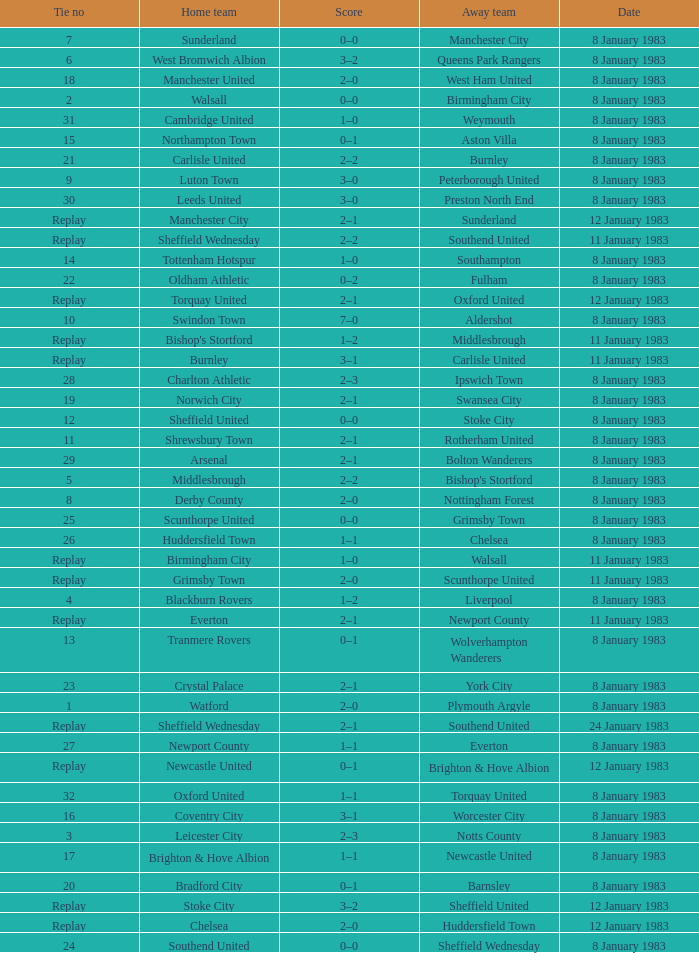On what date was Tie #26 played? 8 January 1983. 